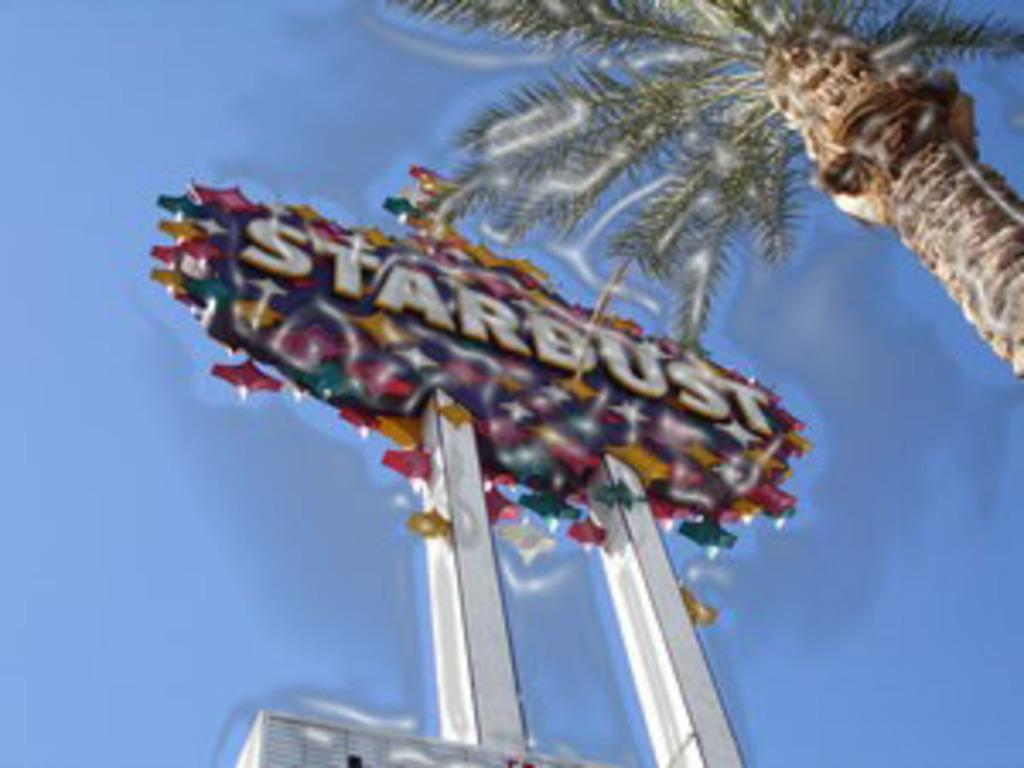What can be seen on the right side top of the image? There is a tree on the right side top of the image. What is located in the middle of the image? There is a hoarding in the middle of the image. What is written or displayed on the hoarding? There is some text on the hoarding. Can you see a giraffe kicking a property in the image? No, there is no giraffe or property present in the image. 